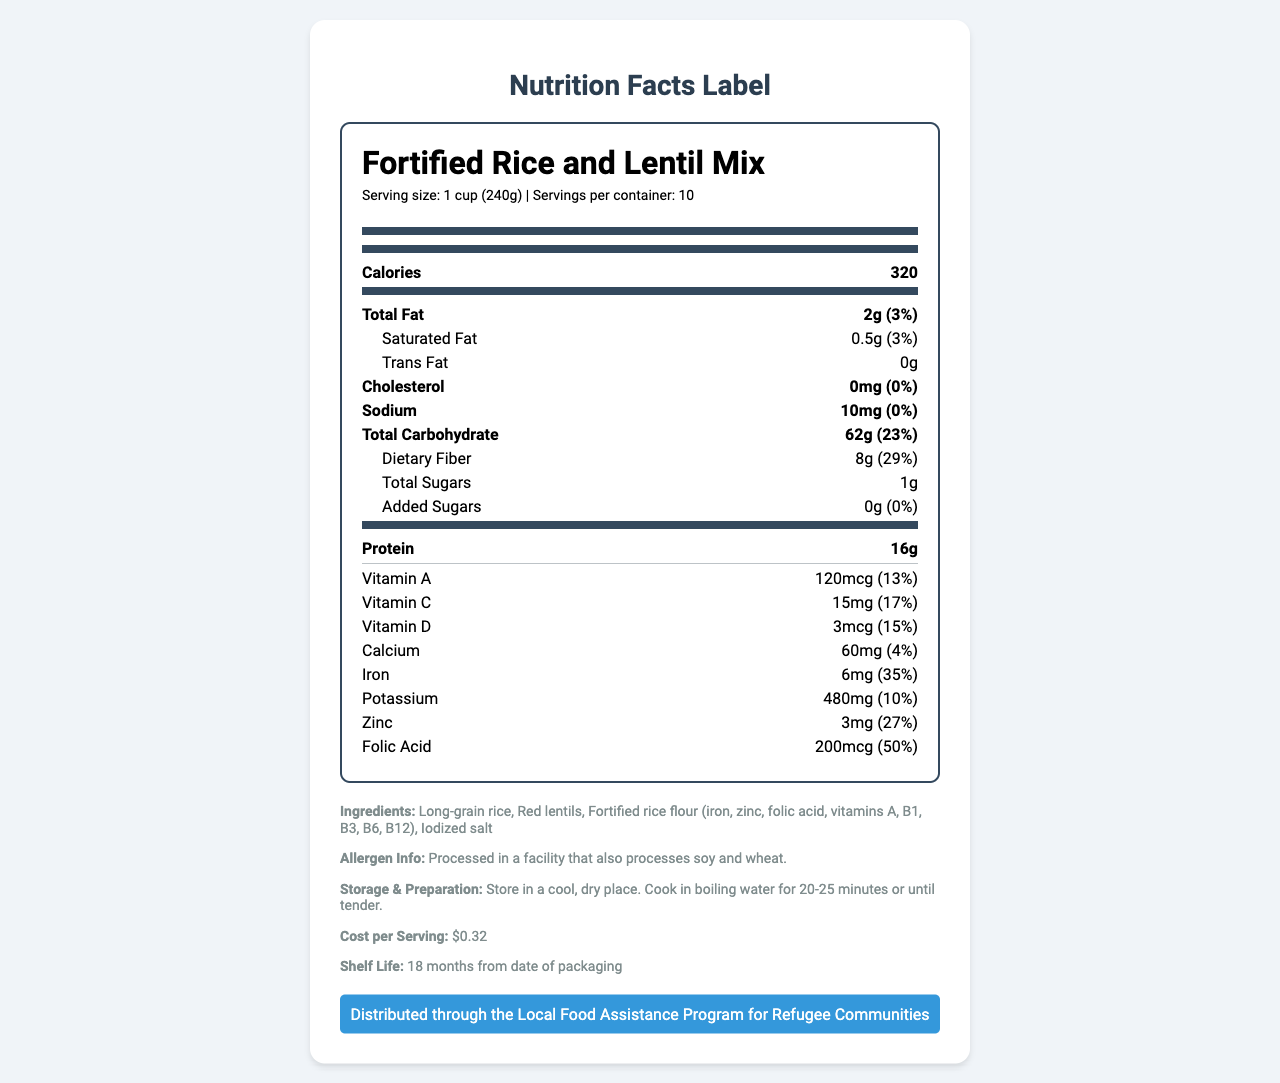who produces the Fortified Rice and Lentil Mix? The document does not provide information about the producer of the Fortified Rice and Lentil Mix.
Answer: Cannot be determined how many servings are there per container? The document states that there are 10 servings per container.
Answer: 10 what is the serving size of the Fortified Rice and Lentil Mix? The serving size is mentioned as 1 cup (240g) in the document.
Answer: 1 cup (240g) how many calories are in one serving? The document lists 320 calories per serving.
Answer: 320 what is the total fat content per serving? The total fat content per serving is 2g, which is 3% of the daily value.
Answer: 2g (3%) how much protein is in each serving? Each serving contains 16g of protein, according to the document.
Answer: 16g does the Fortified Rice and Lentil Mix have any cholesterol? The nutrition facts label indicates that there is 0mg of cholesterol per serving.
Answer: No, 0mg what percentage of the daily recommended amount of iron does one serving provide? Each serving provides 35% of the daily recommended amount of iron.
Answer: 35% what are the main ingredients in this product? The main ingredients listed are long-grain rice, red lentils, fortified rice flour, and iodized salt.
Answer: Long-grain rice, Red lentils, Fortified rice flour, Iodized salt how should the Fortified Rice and Lentil Mix be stored? The storage information specifies that it should be stored in a cool, dry place.
Answer: In a cool, dry place how should the Fortified Rice and Lentil Mix be prepared? The preparation instructions state to cook it in boiling water for 20-25 minutes or until tender.
Answer: Cook in boiling water for 20-25 minutes or until tender what is the cost per serving of this product? A. $0.25 B. $0.32 C. $0.50 D. $1.00 The document indicates that the cost per serving is $0.32.
Answer: B. $0.32 how much dietary fiber is in one serving? A. 2g B. 4g C. 6g D. 8g The document states that there are 8g of dietary fiber per serving.
Answer: D. 8g are there any added sugars in the Fortified Rice and Lentil Mix? According to the nutrition facts label, there are 0g of added sugars.
Answer: No, 0g does this product contain soy or wheat? The allergen info states that it is processed in a facility that also processes soy and wheat, though it does not necessarily contain these allergens.
Answer: Not directly, but processed in a facility that also processes soy and wheat summarize the key points of this document. The explanation provides detailed information found in various sections of the nutrition facts label, from nutritional content to storage instructions, cost, and allergen information.
Answer: This document is a nutrition facts label for a product called Fortified Rice and Lentil Mix. Each serving is 1 cup (240g), with a total of 10 servings per container. The mix contains 320 calories per serving, along with 2g of total fat, 8g of dietary fiber, and 16g of protein. It is fortified with various vitamins and minerals, including Vitamin A, Vitamin C, Vitamin D, calcium, iron, potassium, zinc, and folic acid. It should be stored in a cool, dry place and prepared by cooking in boiling water for 20-25 minutes. The cost per serving is $0.32, and it has a shelf life of 18 months. The product is processed in a facility that also handles soy and wheat. The mix is distributed through the Local Food Assistance Program for Refugee Communities. how does the Fortified Rice and Lentil Mix contribute to daily iron intake? Each serving provides 6mg of iron, which is 35% of the daily value, as indicated in the nutrition facts.
Answer: It contributes 35% of the daily iron intake per serving is this product part of a local government program? The document mentions that it is distributed through the Local Food Assistance Program for Refugee Communities.
Answer: Yes 